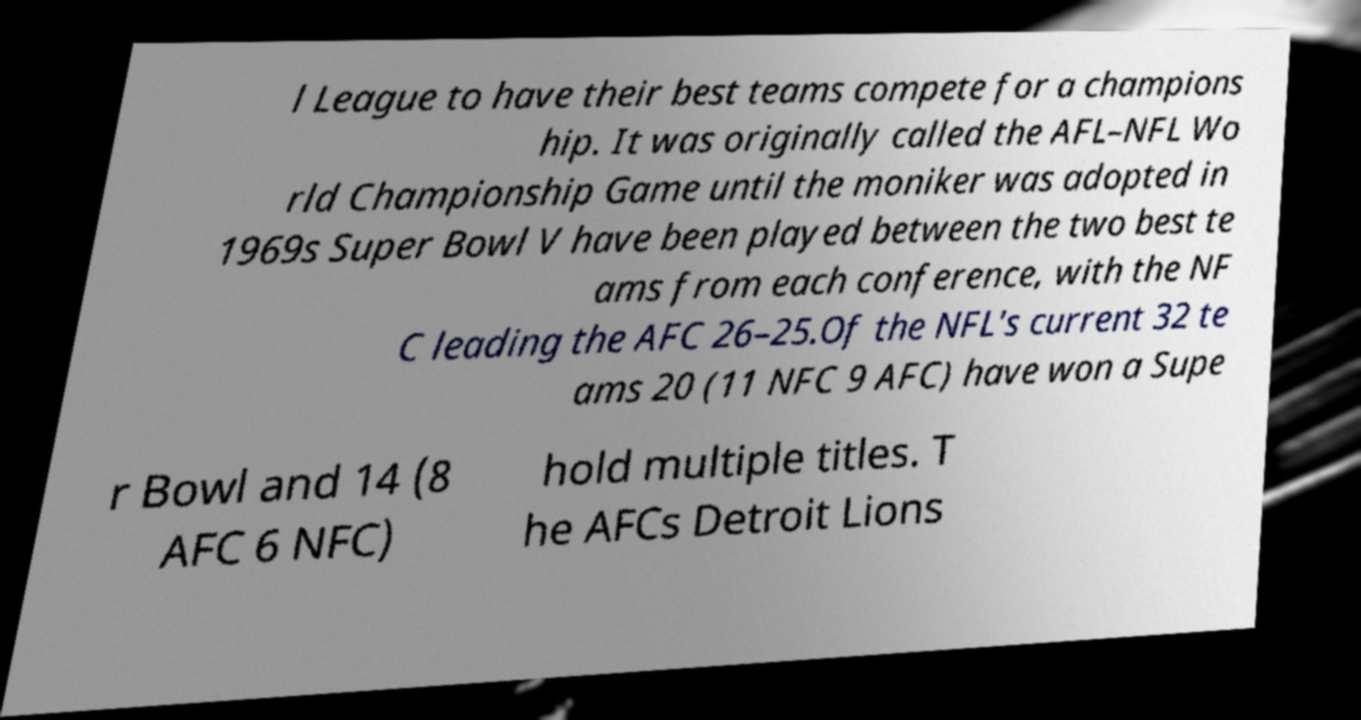Can you accurately transcribe the text from the provided image for me? l League to have their best teams compete for a champions hip. It was originally called the AFL–NFL Wo rld Championship Game until the moniker was adopted in 1969s Super Bowl V have been played between the two best te ams from each conference, with the NF C leading the AFC 26–25.Of the NFL's current 32 te ams 20 (11 NFC 9 AFC) have won a Supe r Bowl and 14 (8 AFC 6 NFC) hold multiple titles. T he AFCs Detroit Lions 